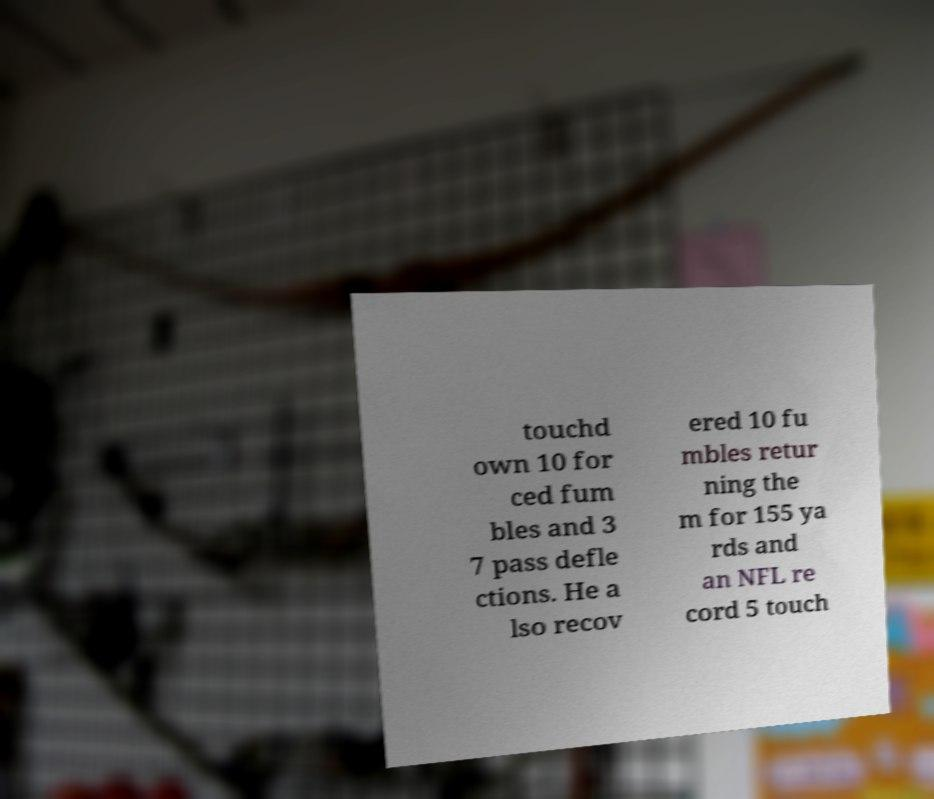Please read and relay the text visible in this image. What does it say? touchd own 10 for ced fum bles and 3 7 pass defle ctions. He a lso recov ered 10 fu mbles retur ning the m for 155 ya rds and an NFL re cord 5 touch 